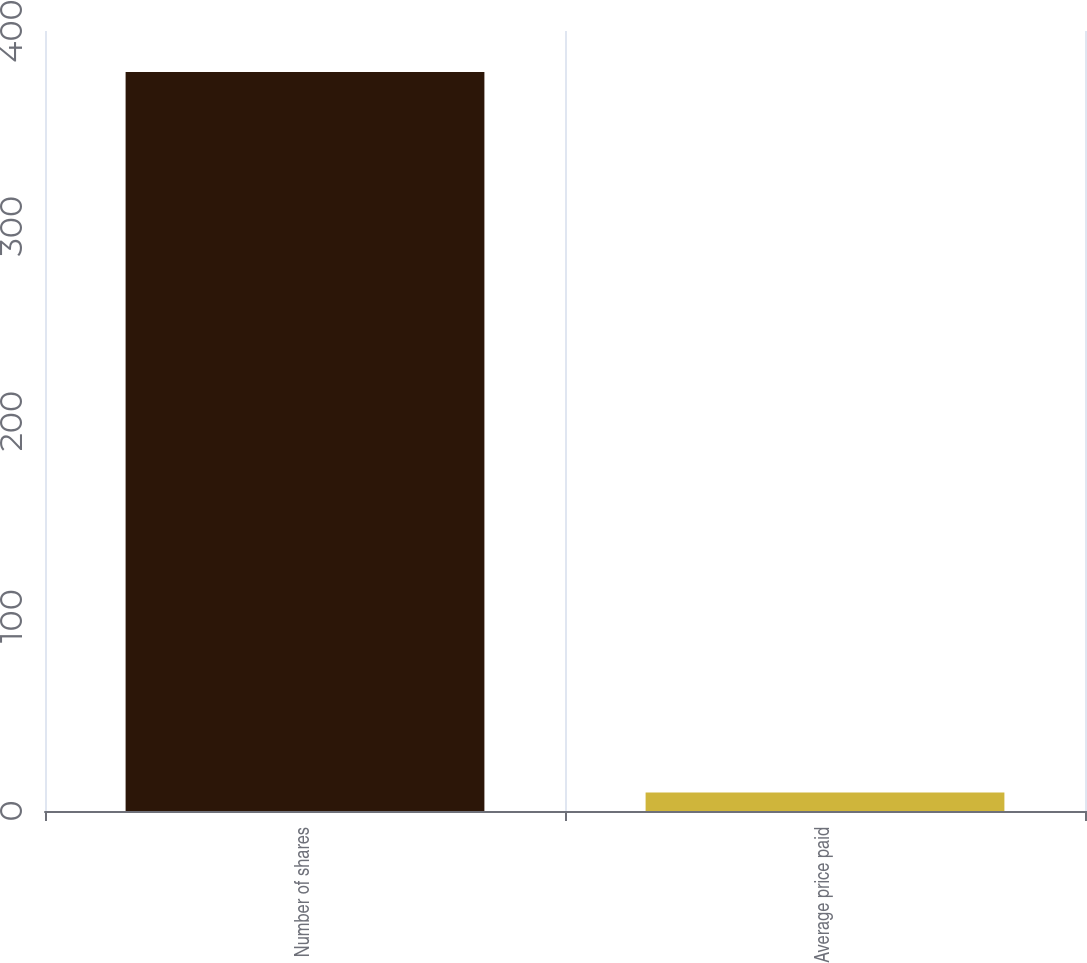<chart> <loc_0><loc_0><loc_500><loc_500><bar_chart><fcel>Number of shares<fcel>Average price paid<nl><fcel>379<fcel>9.49<nl></chart> 